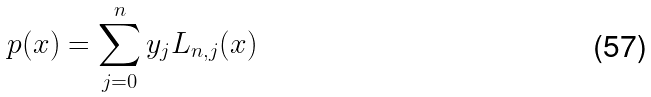Convert formula to latex. <formula><loc_0><loc_0><loc_500><loc_500>p ( x ) = \sum _ { j = 0 } ^ { n } y _ { j } L _ { n , j } ( x )</formula> 